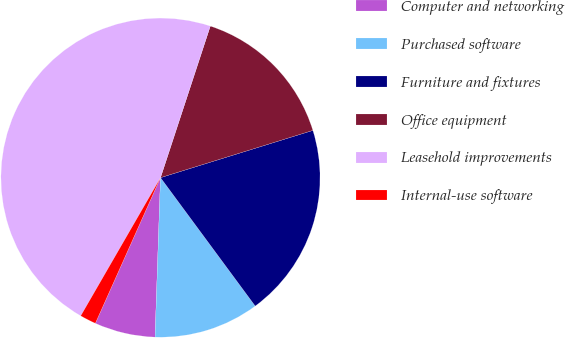Convert chart. <chart><loc_0><loc_0><loc_500><loc_500><pie_chart><fcel>Computer and networking<fcel>Purchased software<fcel>Furniture and fixtures<fcel>Office equipment<fcel>Leasehold improvements<fcel>Internal-use software<nl><fcel>6.15%<fcel>10.66%<fcel>19.67%<fcel>15.16%<fcel>46.72%<fcel>1.64%<nl></chart> 